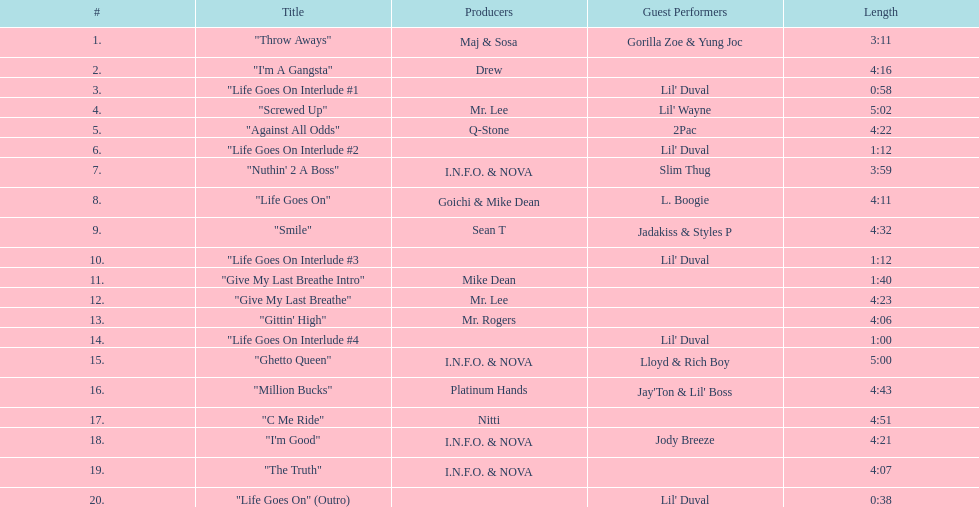What is the total number of tracks on the album? 20. 